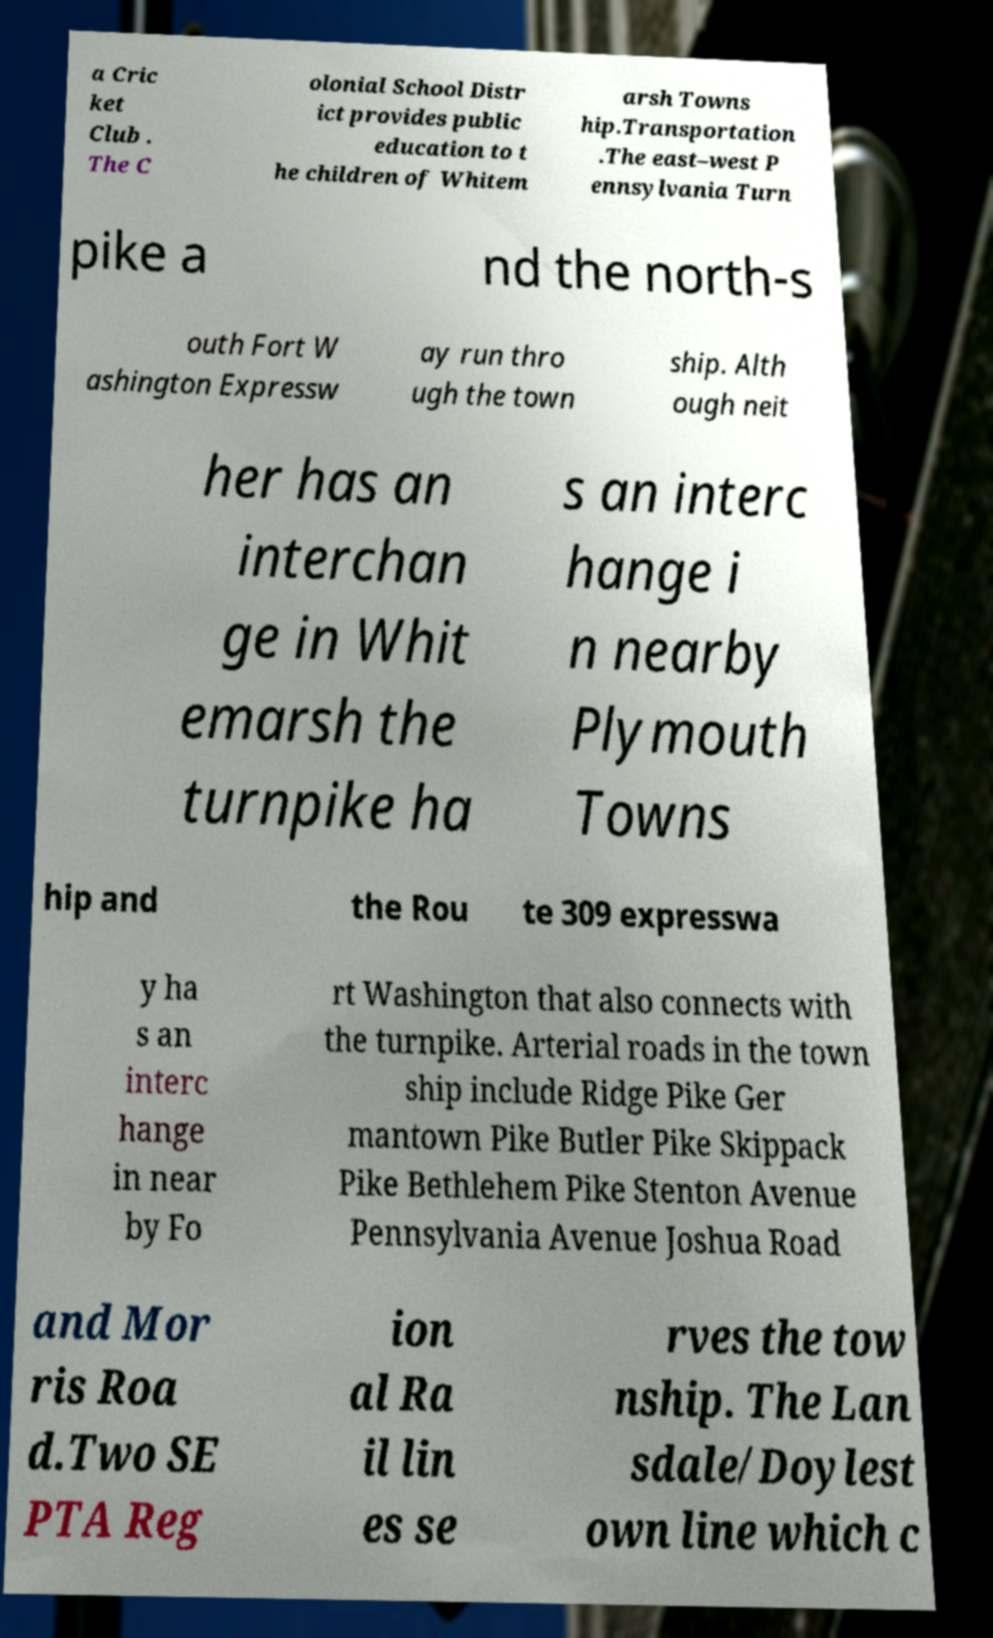What messages or text are displayed in this image? I need them in a readable, typed format. a Cric ket Club . The C olonial School Distr ict provides public education to t he children of Whitem arsh Towns hip.Transportation .The east–west P ennsylvania Turn pike a nd the north-s outh Fort W ashington Expressw ay run thro ugh the town ship. Alth ough neit her has an interchan ge in Whit emarsh the turnpike ha s an interc hange i n nearby Plymouth Towns hip and the Rou te 309 expresswa y ha s an interc hange in near by Fo rt Washington that also connects with the turnpike. Arterial roads in the town ship include Ridge Pike Ger mantown Pike Butler Pike Skippack Pike Bethlehem Pike Stenton Avenue Pennsylvania Avenue Joshua Road and Mor ris Roa d.Two SE PTA Reg ion al Ra il lin es se rves the tow nship. The Lan sdale/Doylest own line which c 